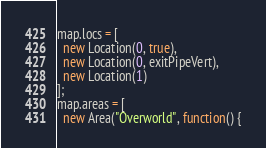Convert code to text. <code><loc_0><loc_0><loc_500><loc_500><_JavaScript_>map.locs = [
  new Location(0, true),
  new Location(0, exitPipeVert),
  new Location(1)
];
map.areas = [
  new Area("Overworld", function() {</code> 